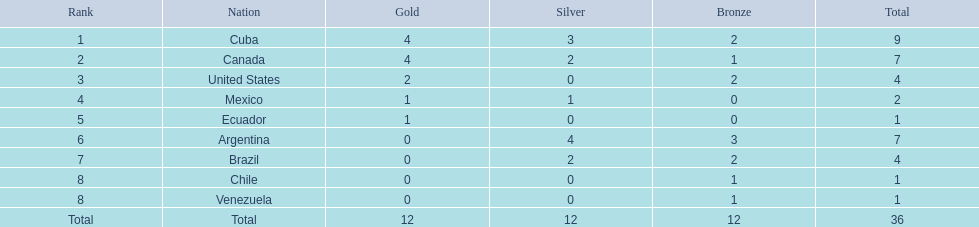Which countries secured gold medals? Cuba, Canada, United States, Mexico, Ecuador. How many medals did each country achieve? Cuba, 9, Canada, 7, United States, 4, Mexico, 2, Ecuador, 1. Which country exclusively gained a gold medal? Ecuador. 